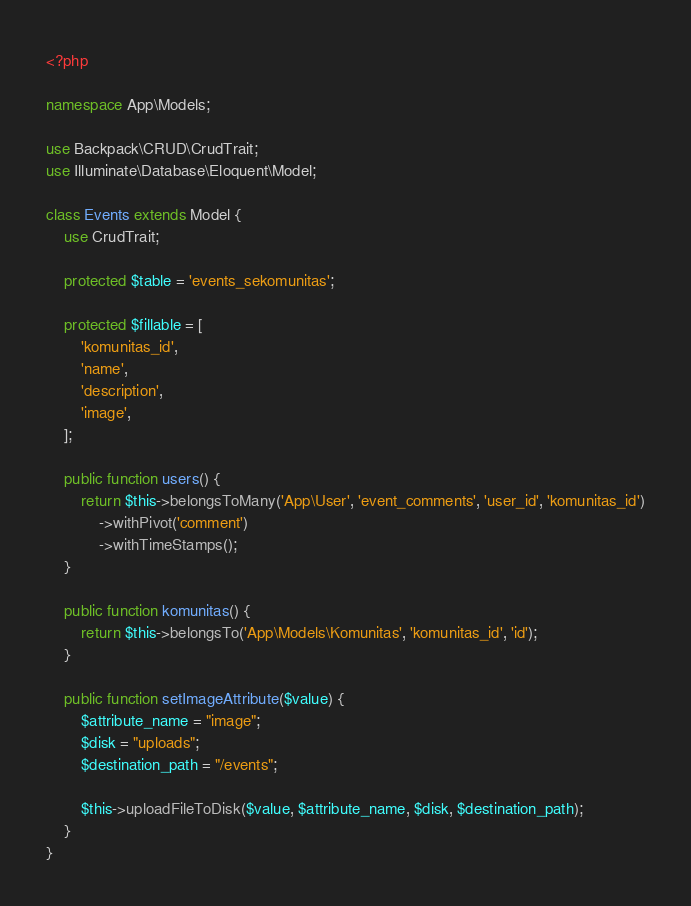<code> <loc_0><loc_0><loc_500><loc_500><_PHP_><?php

namespace App\Models;

use Backpack\CRUD\CrudTrait;
use Illuminate\Database\Eloquent\Model;

class Events extends Model {
	use CrudTrait;

	protected $table = 'events_sekomunitas';

	protected $fillable = [
		'komunitas_id',
		'name',
		'description',
		'image',
	];

	public function users() {
		return $this->belongsToMany('App\User', 'event_comments', 'user_id', 'komunitas_id')
			->withPivot('comment')
			->withTimeStamps();
	}

	public function komunitas() {
		return $this->belongsTo('App\Models\Komunitas', 'komunitas_id', 'id');
	}

	public function setImageAttribute($value) {
		$attribute_name = "image";
		$disk = "uploads";
		$destination_path = "/events";

		$this->uploadFileToDisk($value, $attribute_name, $disk, $destination_path);
	}
}
</code> 